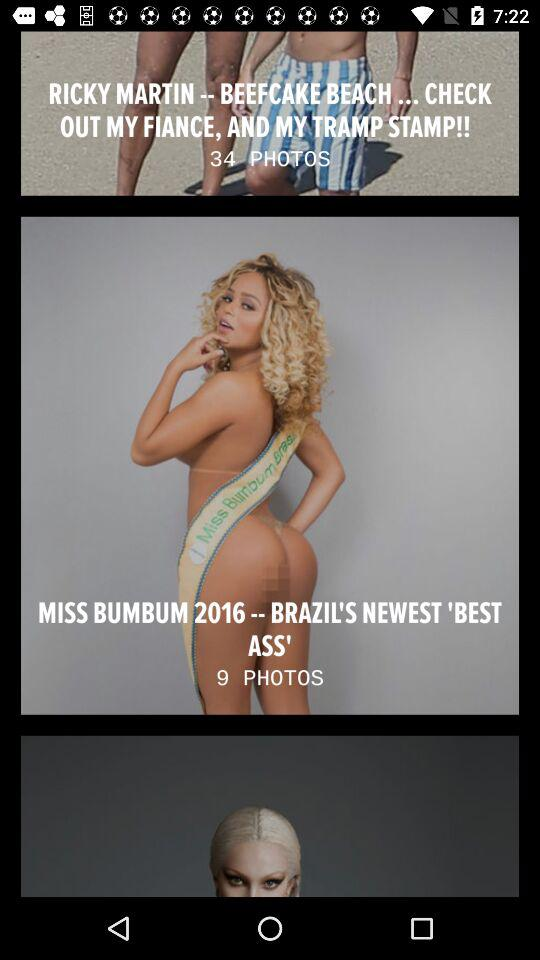How many total photos of Rickey Martin are there? There are 34 photos. 